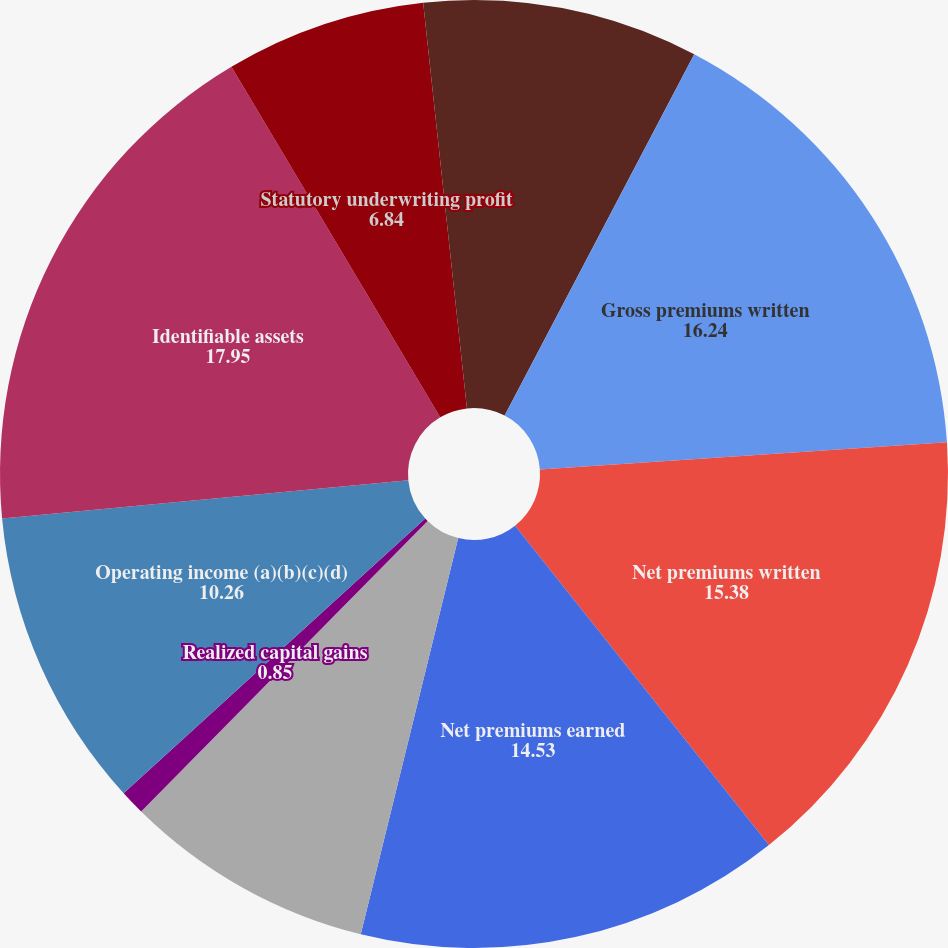<chart> <loc_0><loc_0><loc_500><loc_500><pie_chart><fcel>Years Ended December 31 (in<fcel>Gross premiums written<fcel>Net premiums written<fcel>Net premiums earned<fcel>Net investment income (a)<fcel>Realized capital gains<fcel>Operating income (a)(b)(c)(d)<fcel>Identifiable assets<fcel>Statutory underwriting profit<fcel>Loss ratio<nl><fcel>7.69%<fcel>16.24%<fcel>15.38%<fcel>14.53%<fcel>8.55%<fcel>0.85%<fcel>10.26%<fcel>17.95%<fcel>6.84%<fcel>1.71%<nl></chart> 